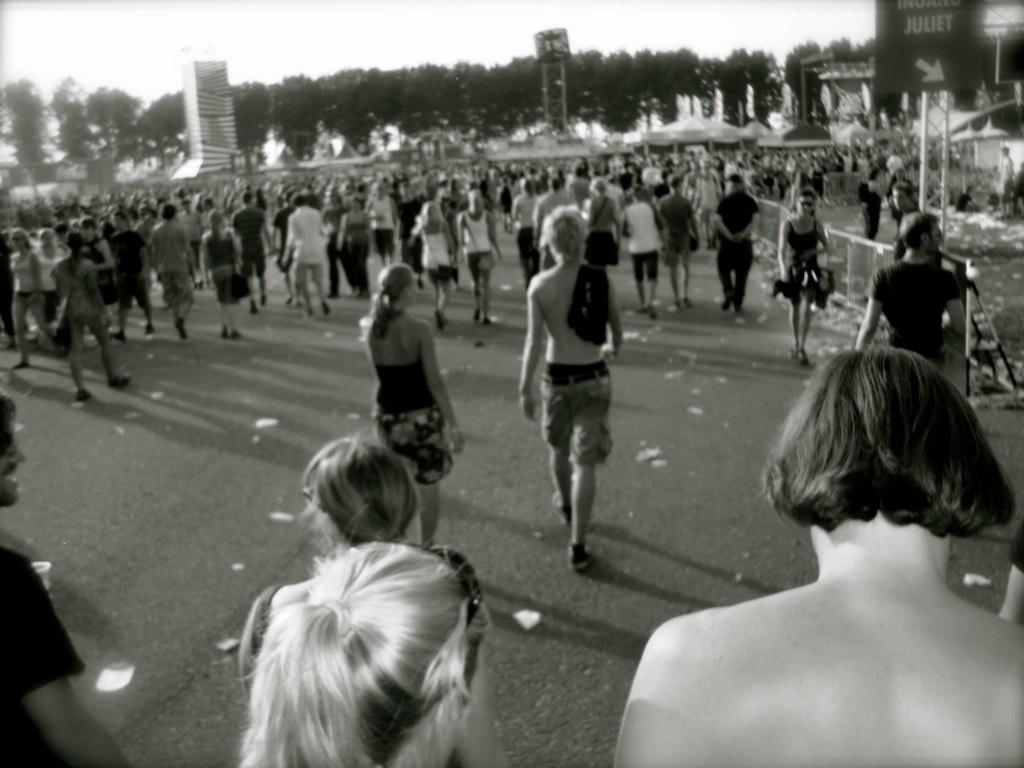Can you describe this image briefly? This image consists of a crowd on the road, fence, trees, buildings, board and the sky. This image is taken may be on the road. 